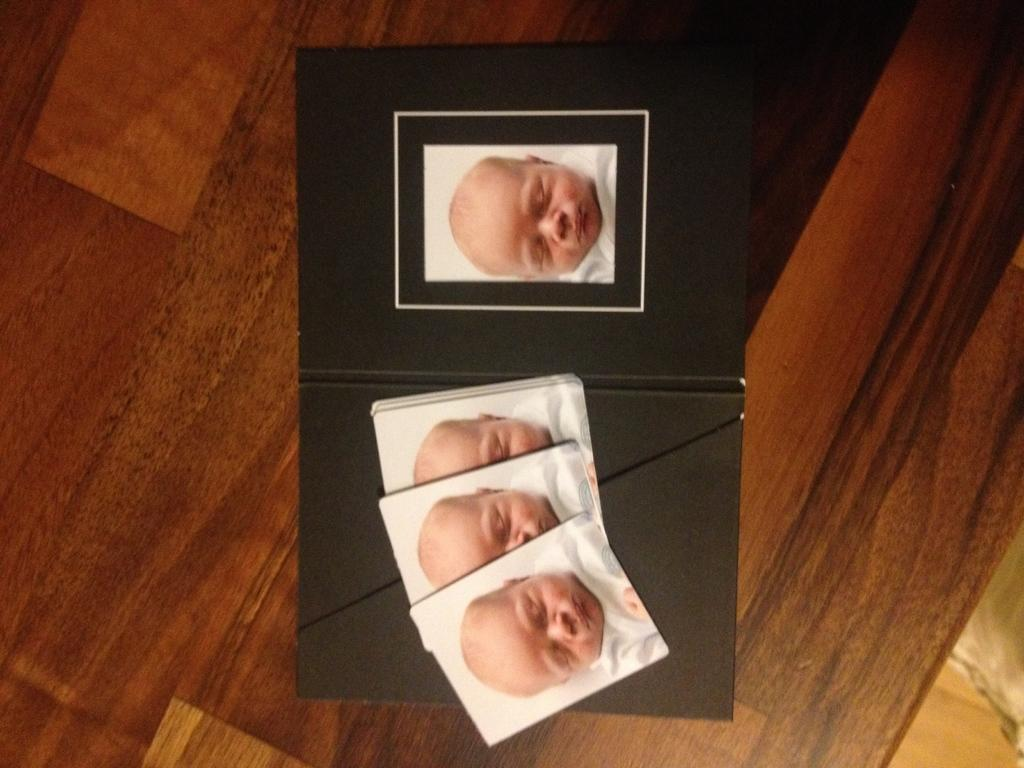What type of items are present in the image? There are photographs in the image. How are the photographs organized in the image? The photographs are in a black color file. What is the material of the surface where the file is placed? The file is kept on a wooden surface. What type of fiction is being experienced by the photographs in the image? There is no indication of any fiction or experience in the image; it simply shows photographs in a black color file on a wooden surface. 